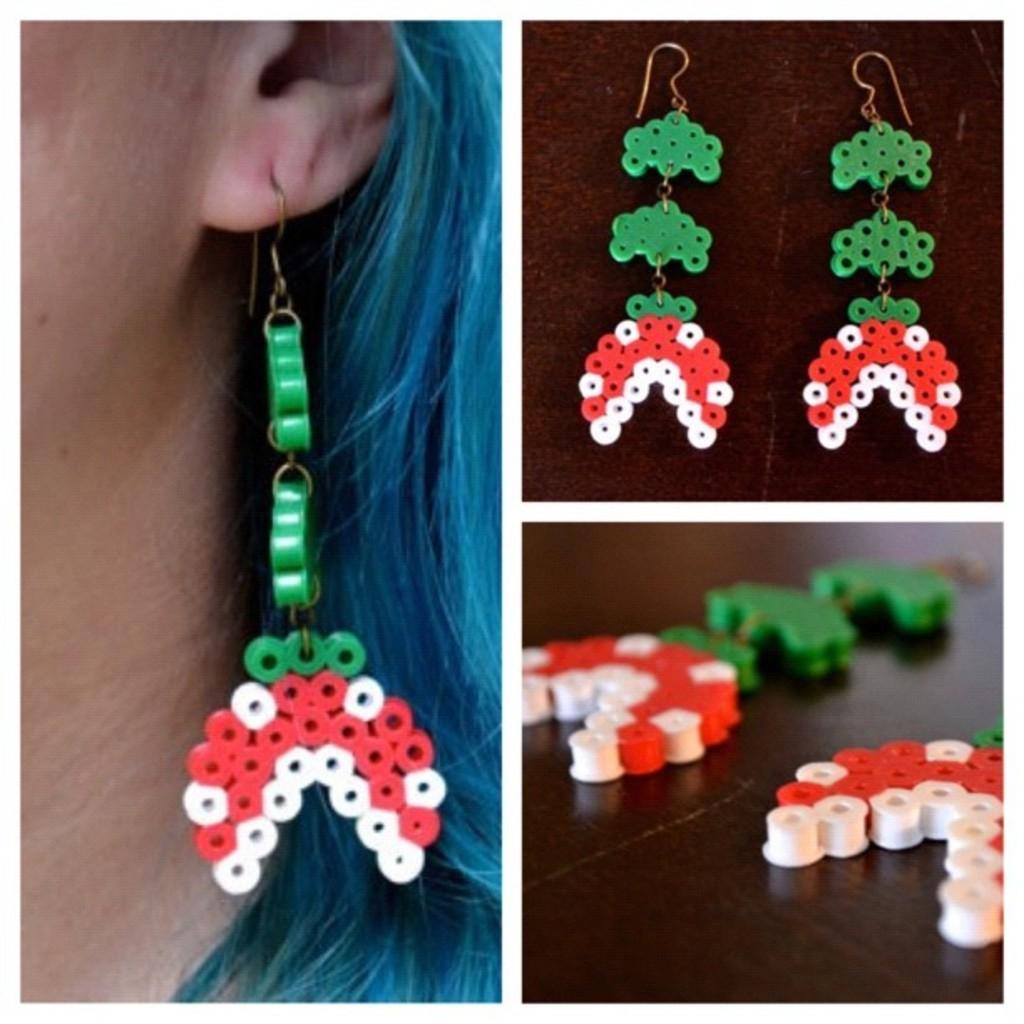How would you summarize this image in a sentence or two? This is a collage image. Here I can see three pictures which consists of same earrings. In the left side image, I can see a person wearing these earrings. 